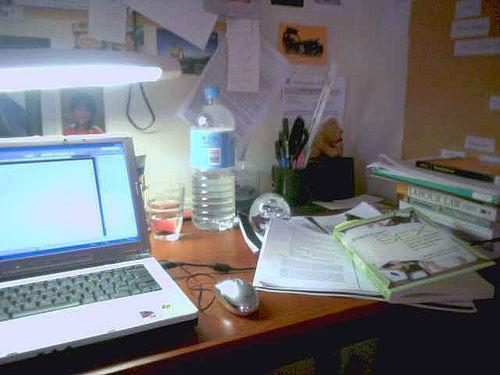What might sit in the glass?
Select the accurate answer and provide explanation: 'Answer: answer
Rationale: rationale.'
Options: Dentures, nothing, wine, pencils. Answer: dentures.
Rationale: The dentures sit in the glass. 